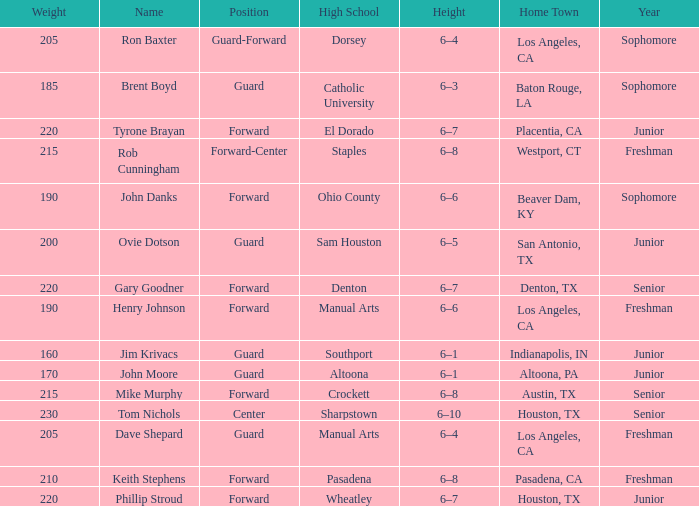What is the Name with a Year with freshman, and a Home Town with los angeles, ca, and a Height of 6–4? Dave Shepard. 